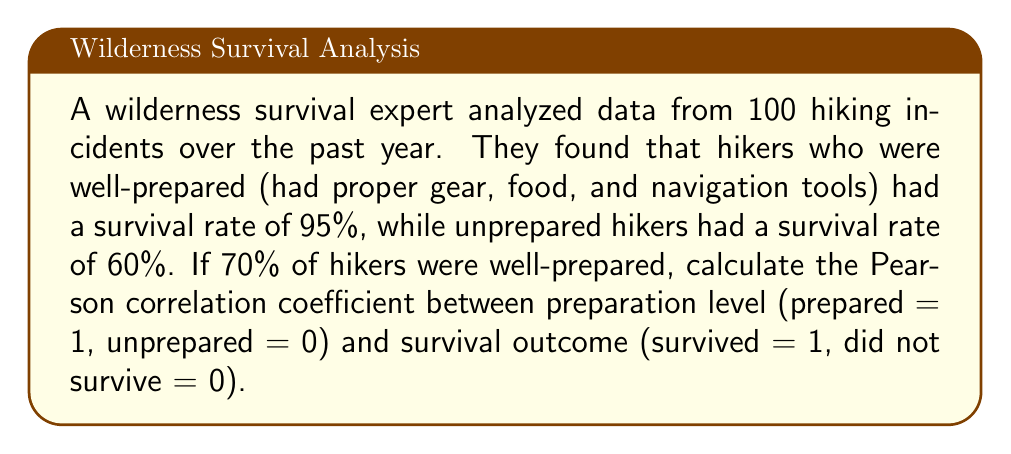Help me with this question. To calculate the Pearson correlation coefficient, we'll follow these steps:

1. Set up a 2x2 contingency table:
   
   | Preparation | Survived | Did not survive | Total |
   |-------------|----------|-----------------|-------|
   | Prepared    | 66.5     | 3.5             | 70    |
   | Unprepared  | 18       | 12              | 30    |
   | Total       | 84.5     | 15.5            | 100   |

2. Calculate means:
   $\bar{x} = 0.70$ (mean of preparation)
   $\bar{y} = 0.845$ (mean of survival)

3. Calculate standard deviations:
   $s_x = \sqrt{0.70 * 0.30} = 0.4583$
   $s_y = \sqrt{0.845 * 0.155} = 0.3620$

4. Calculate covariance:
   $cov(x,y) = \frac{(1-0.70)(1-0.845) * 66.5 + (1-0.70)(0-0.845) * 3.5 + (0-0.70)(1-0.845) * 18 + (0-0.70)(0-0.845) * 12}{100-1}$
   $= 0.0678$

5. Apply the Pearson correlation coefficient formula:
   $$r = \frac{cov(x,y)}{s_x * s_y} = \frac{0.0678}{0.4583 * 0.3620} = 0.4092$$
Answer: 0.4092 